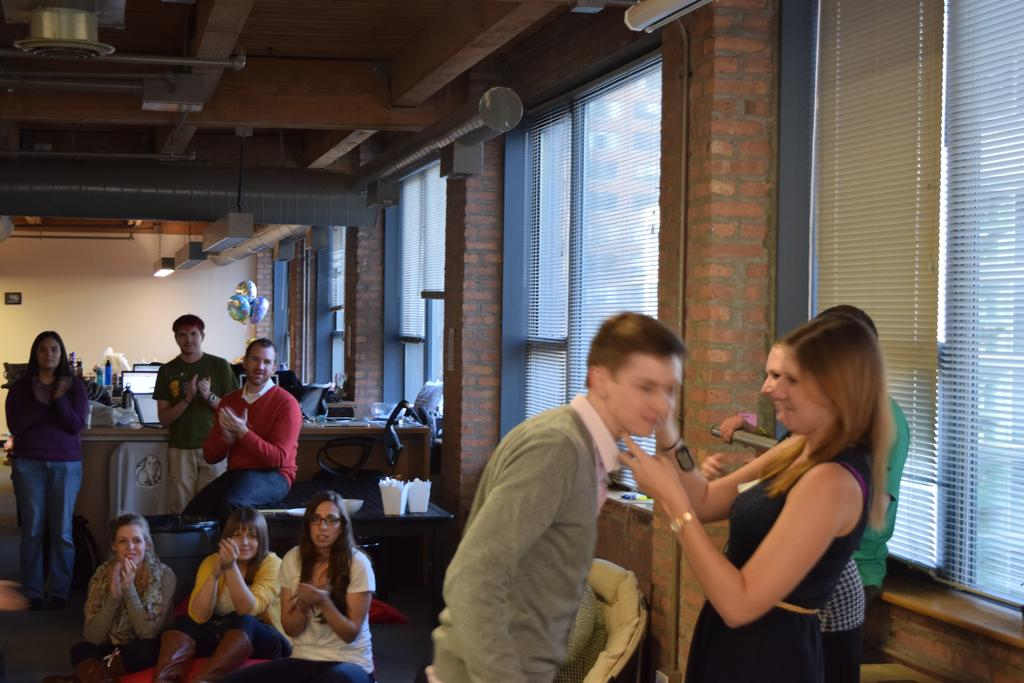How many people are in the image? There is a group of people in the image, but the exact number is not specified. What are the people in the image doing? Some people are sitting, while others are standing. What can be seen in the background of the image? There are window blinds, lights, and balloons in the background of the image. What type of needle is being used by the expert in the image? There is no needle or expert present in the image. How many eyes can be seen on the people in the image? The number of eyes on the people in the image is not specified, but it can be assumed that each person has two eyes. 